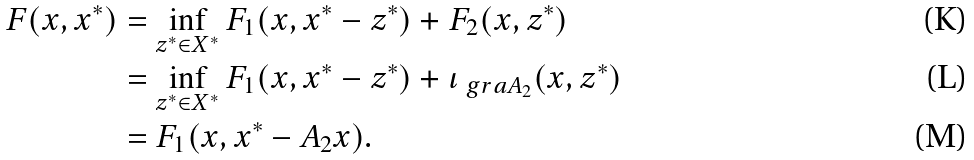<formula> <loc_0><loc_0><loc_500><loc_500>F ( x , x ^ { * } ) & = \inf _ { z ^ { * } \in X ^ { * } } F _ { 1 } ( x , x ^ { * } - z ^ { * } ) + F _ { 2 } ( x , z ^ { * } ) \\ & = \inf _ { z ^ { * } \in X ^ { * } } F _ { 1 } ( x , x ^ { * } - z ^ { * } ) + \iota _ { \ g r a A _ { 2 } } ( x , z ^ { * } ) \\ & = F _ { 1 } ( x , x ^ { * } - A _ { 2 } x ) .</formula> 